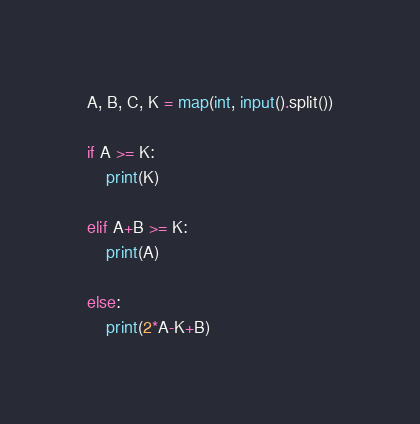Convert code to text. <code><loc_0><loc_0><loc_500><loc_500><_Python_>A, B, C, K = map(int, input().split())

if A >= K:
    print(K)
    
elif A+B >= K:
    print(A)
    
else:
    print(2*A-K+B)</code> 